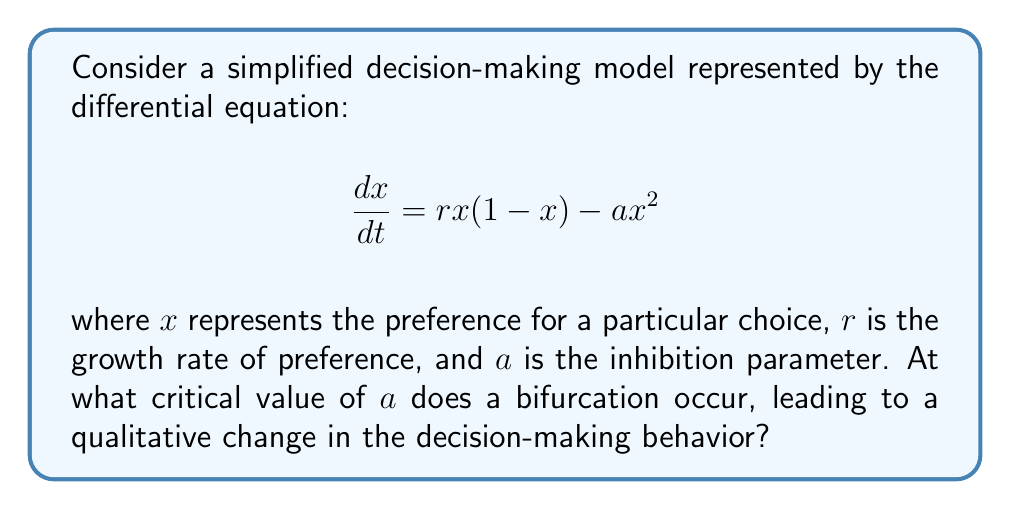Show me your answer to this math problem. To find the bifurcation point, we need to follow these steps:

1) First, find the equilibrium points by setting $\frac{dx}{dt} = 0$:

   $$rx(1-x) - ax^2 = 0$$
   $$x(r-rx-ax) = 0$$

2) Solve for x:
   $x = 0$ or $r-rx-ax = 0$
   
   For the second equation: $x(r-a) = r$
   $x = \frac{r}{r-a}$ (when $r \neq a$)

3) The bifurcation occurs when these two equilibrium points coincide. This happens when $\frac{r}{r-a} = 0$, or when the denominator approaches infinity.

4) As $r-a$ approaches 0, $\frac{r}{r-a}$ approaches infinity. This occurs when:

   $$r-a = 0$$
   $$a = r$$

5) Therefore, the bifurcation occurs at the critical value $a = r$.

From a philosophical perspective, this bifurcation represents a critical point where the decision-making process undergoes a fundamental change. Before this point, there are two possible stable states (representing two distinct choices). At the bifurcation point, these two states merge into one, suggesting a loss of alternatives in the decision-making process.
Answer: $a = r$ 